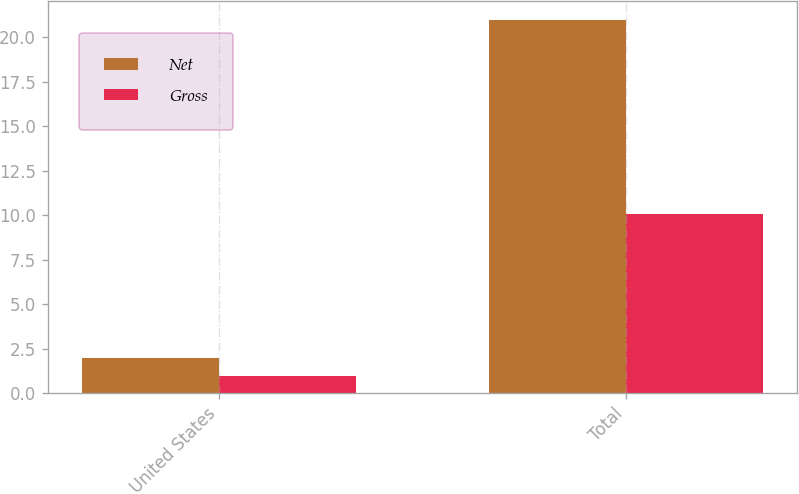<chart> <loc_0><loc_0><loc_500><loc_500><stacked_bar_chart><ecel><fcel>United States<fcel>Total<nl><fcel>Net<fcel>2<fcel>21<nl><fcel>Gross<fcel>1<fcel>10.1<nl></chart> 